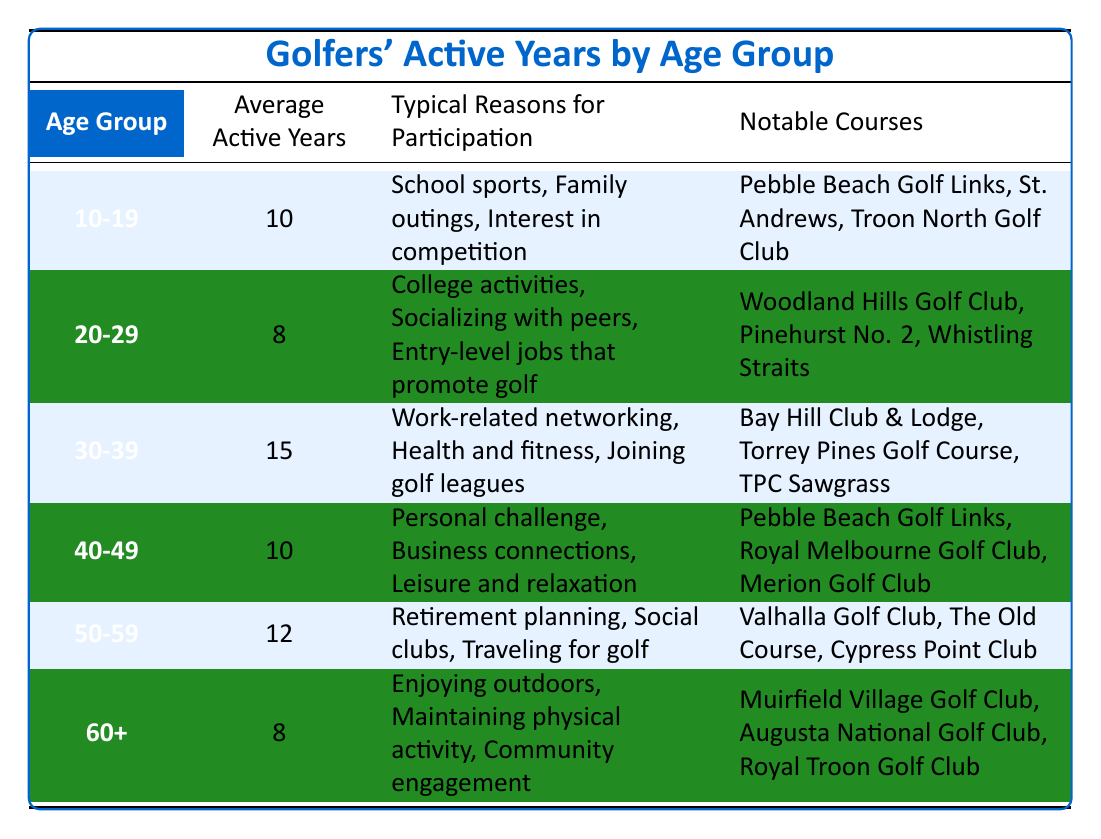What is the average active years for golfers aged 30-39? The table shows that the "Average Active Years" for the age group "30-39" is listed directly under that row, which is 15.
Answer: 15 Which age group has the highest average active years? By scanning through the table, the age group "30-39" has the highest average active years listed, which is 15.
Answer: 30-39 Is the average active years higher for golfers in their 50s compared to those in their 20s? The average active years for the age group "50-59" is 12, while for "20-29" it is 8. Since 12 is greater than 8, the answer is yes.
Answer: Yes What is the sum of average active years for all age groups combined? If we add the average active years for each group: 10 (10-19) + 8 (20-29) + 15 (30-39) + 10 (40-49) + 12 (50-59) + 8 (60+) = 63. The total sum is therefore 63.
Answer: 63 Are the typical reasons for participation in golf different between golfers aged 10-19 and those aged 40-49? The reasons for "10-19" include school sports, family outings, and interest in competition, while for "40-49," they include personal challenge, business connections, and leisure. Since both lists contain different activities, the answer is yes.
Answer: Yes How many notable courses are listed for golfers aged 60 and older? The table indicates three notable courses for the age group "60+", which are listed directly under that category.
Answer: 3 What is the average active years for golfers aged 50-59 compared to those aged 30-39? "50-59" has an average of 12 years, while "30-39" has 15 years. Comparing these numbers shows that 15 is greater than 12, confirming that golfers aged 30-39 are more active on average.
Answer: 30-39 has higher average active years What percentage of average active years do golfers aged 40-49 contribute to the total average active years? First, find the average for "40-49," which is 10, then take the sum of all average active years, 63. The percentage is calculated as (10/63) * 100 ≈ 15.87%.
Answer: Approximately 15.87% Is the average active years for golfers aged 60 and older less than for those aged 10-19? For "60+" the average is 8 and for "10-19" it is 10. Since 8 is less than 10, the answer is yes.
Answer: Yes 